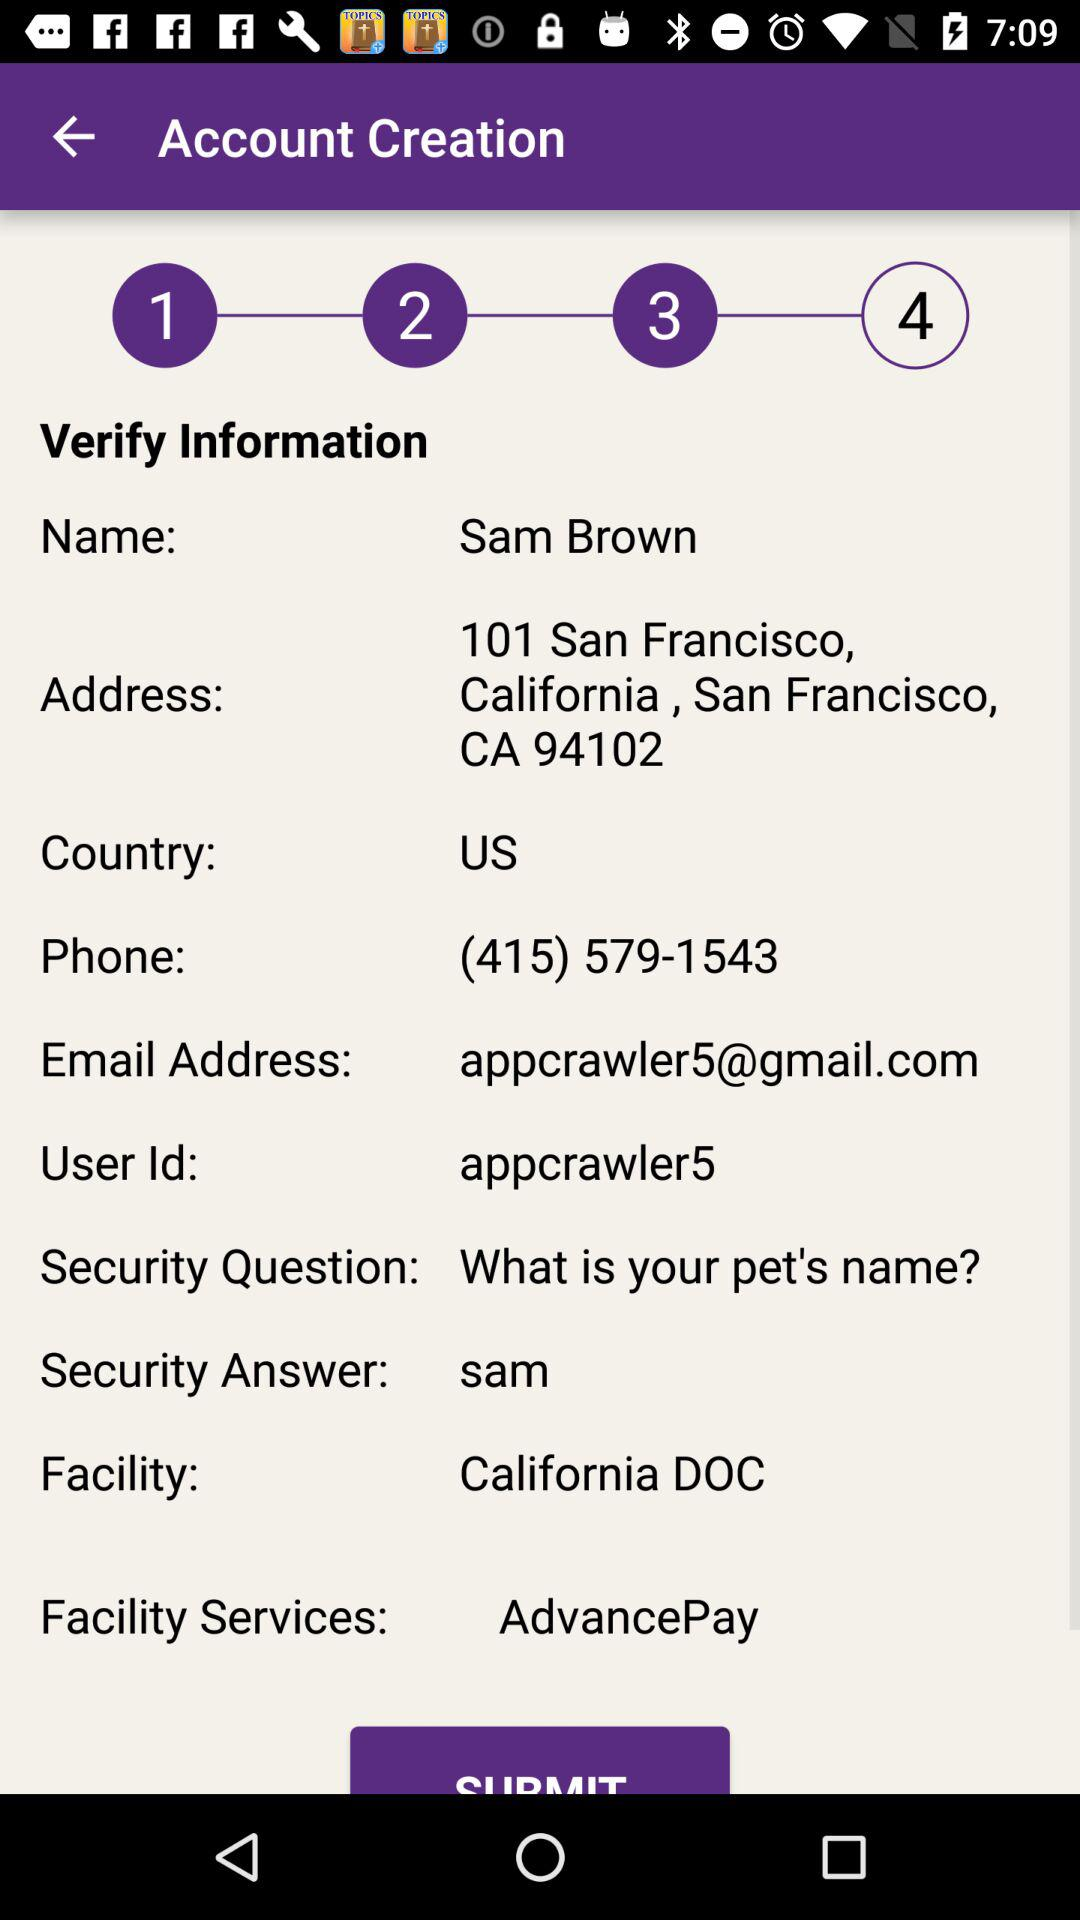What is the "Facility Services"? The "Facility Services" is "AdvancePay". 